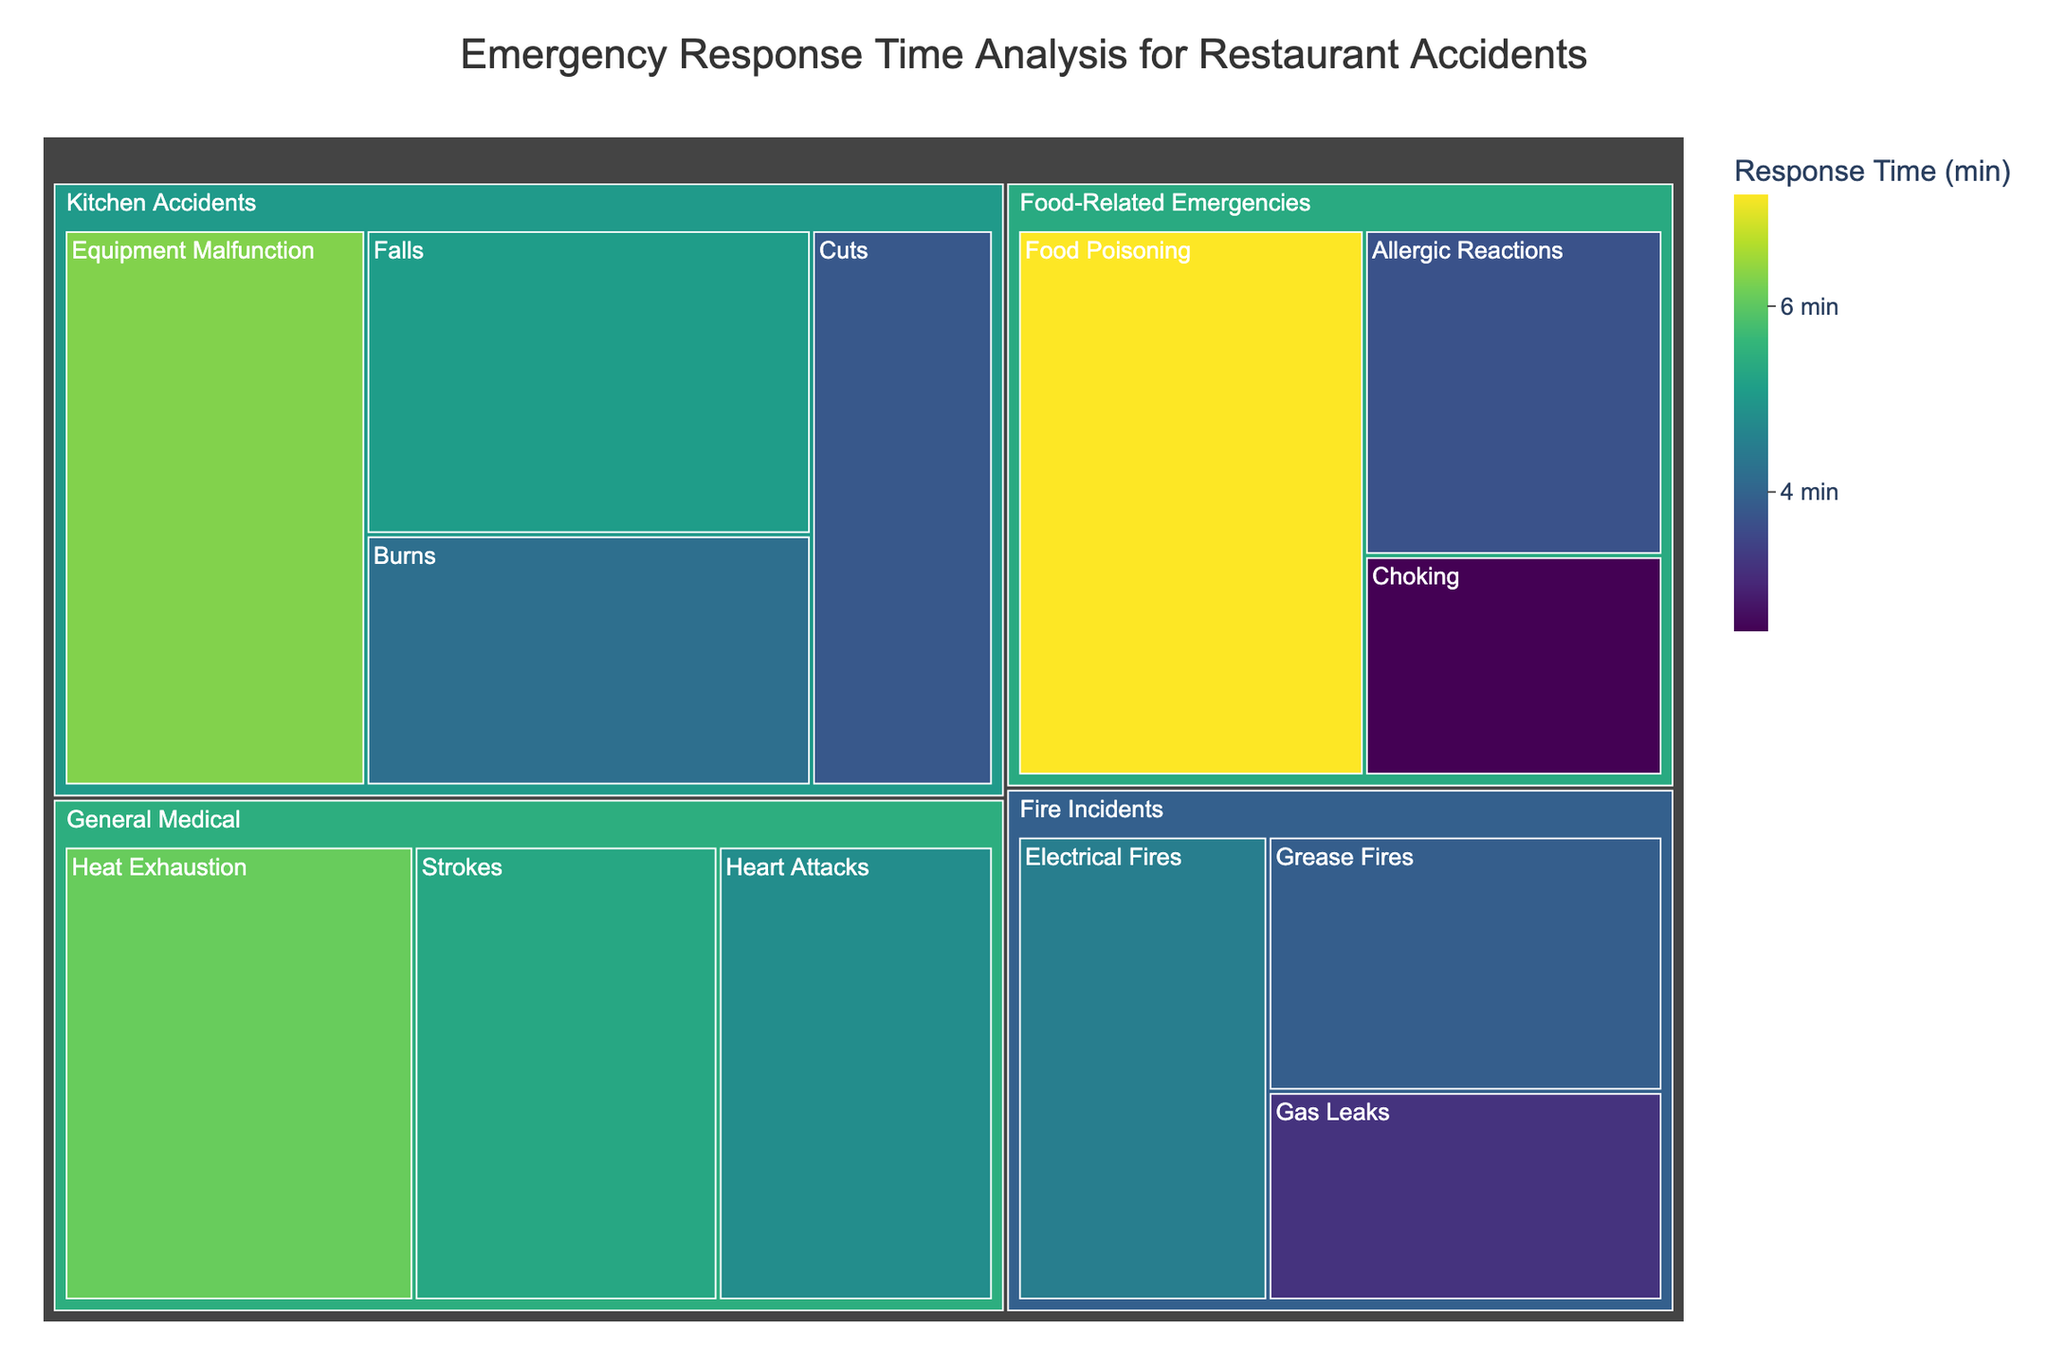What's the title of the treemap? The title of the treemap is usually displayed prominently at the top of the figure. In this case, it should be "Emergency Response Time Analysis for Restaurant Accidents"
Answer: Emergency Response Time Analysis for Restaurant Accidents Which subcategory has the shortest response time? To find the shortest response time, look for the smallest value associated with any subcategory. By visual inspection, "Choking" has the lowest response time of 2.5 minutes.
Answer: Choking Which category has the longest average response time? Calculate the average response time for each category by summing the response times of its subcategories and dividing by the number of subcategories. Compare these averages to determine the longest one. "General Medical" has subcategory times of 4.8, 5.3, and 6.1, making its average (4.8+5.3+6.1)/3 = 5.4, which is higher than other categories.
Answer: General Medical Is the response time for allergic reactions longer or shorter than for cuts? Compare the response time values for "Allergic Reactions" (3.7 minutes) and "Cuts" (3.8 minutes) directly from the figure to determine which is longer.
Answer: Shorter What's the response time difference between grease fires and electrical fires? To find the difference, subtract the response time for "Grease Fires" (3.9 minutes) from "Electrical Fires" (4.5 minutes). The difference is 4.5 - 3.9.
Answer: 0.6 minutes Which category has the most subcategories? Count the number of subcategories under each category by visually inspecting the treemap. "Kitchen Accidents" has the most subcategories: Burns, Cuts, Falls, Equipment Malfunction.
Answer: Kitchen Accidents What is the median response time for subcategories within Food-Related Emergencies? To find the median, first list the response times for subcategories within "Food-Related Emergencies": 2.5, 3.7, 7.2. Since there are three values, the median is the middle value, 3.7.
Answer: 3.7 Within the category of Fire Incidents, which subcategory has the lowest response time? Visually inspect the subcategories under "Fire Incidents" to find the one with the lowest value. "Gas Leaks" has the lowest response time of 3.2 minutes.
Answer: Gas Leaks Does the "Heat Exhaustion" subcategory have a higher response time compared to "Falls"? Compare the response times directly. "Heat Exhaustion" has a response time of 6.1 minutes, and "Falls" has 5.1 minutes.
Answer: Yes What is the combined response time for all subcategories under Kitchen Accidents? Sum the response times of all subcategories under "Kitchen Accidents": 4.2, 3.8, 5.1, and 6.3. The combined response time is 4.2 + 3.8 + 5.1 + 6.3.
Answer: 19.4 minutes 